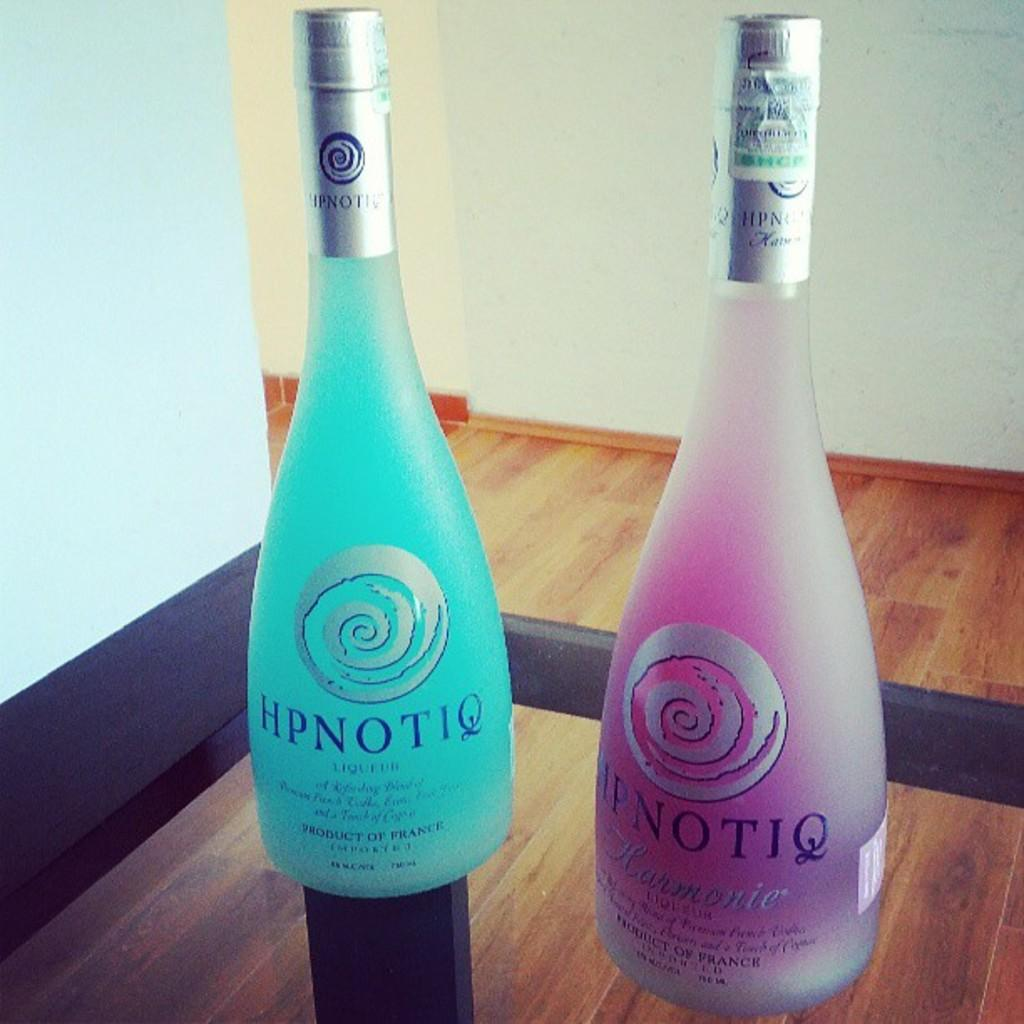<image>
Offer a succinct explanation of the picture presented. A bottle of blue Hpnotiq and a bottle of purple Hpnotiq are next to each other on a table. 